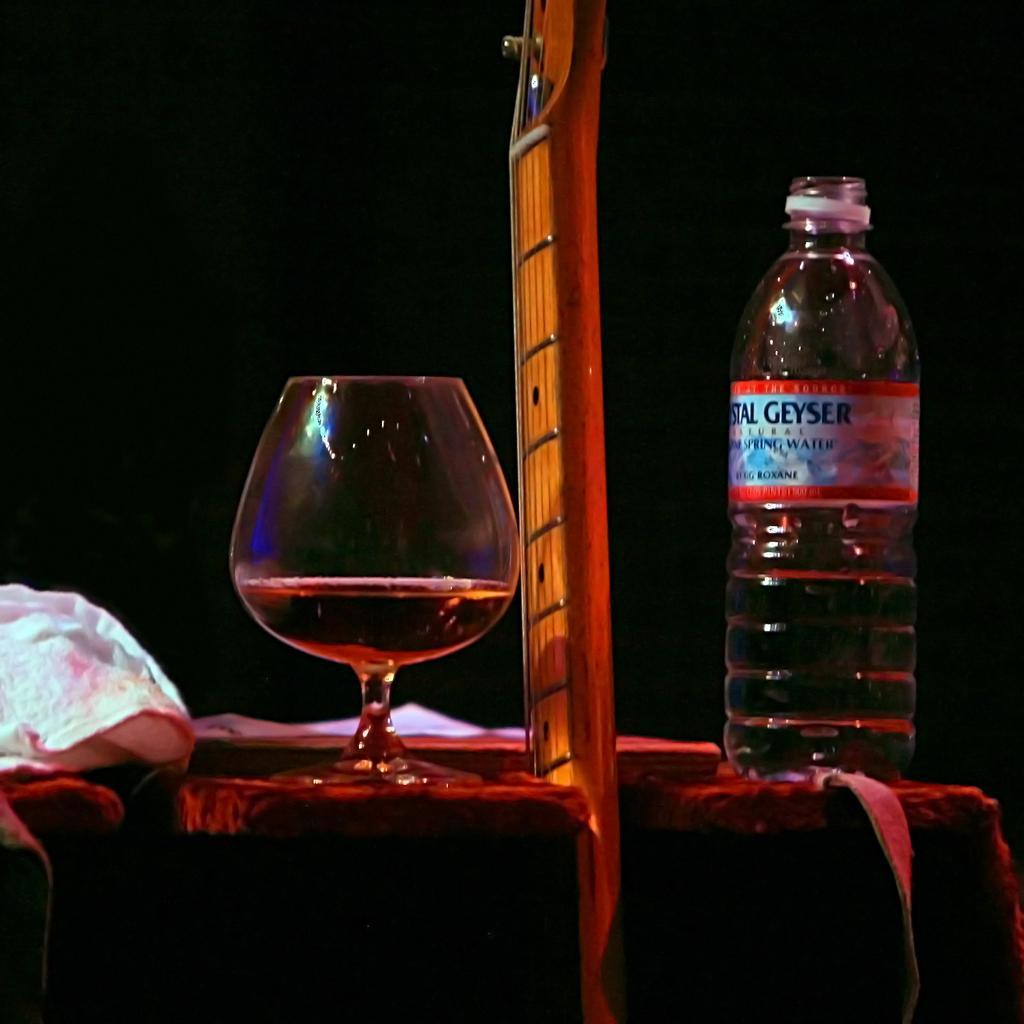In one or two sentences, can you explain what this image depicts? In this picture we can see one bottle and one glass filled with a liquid. 